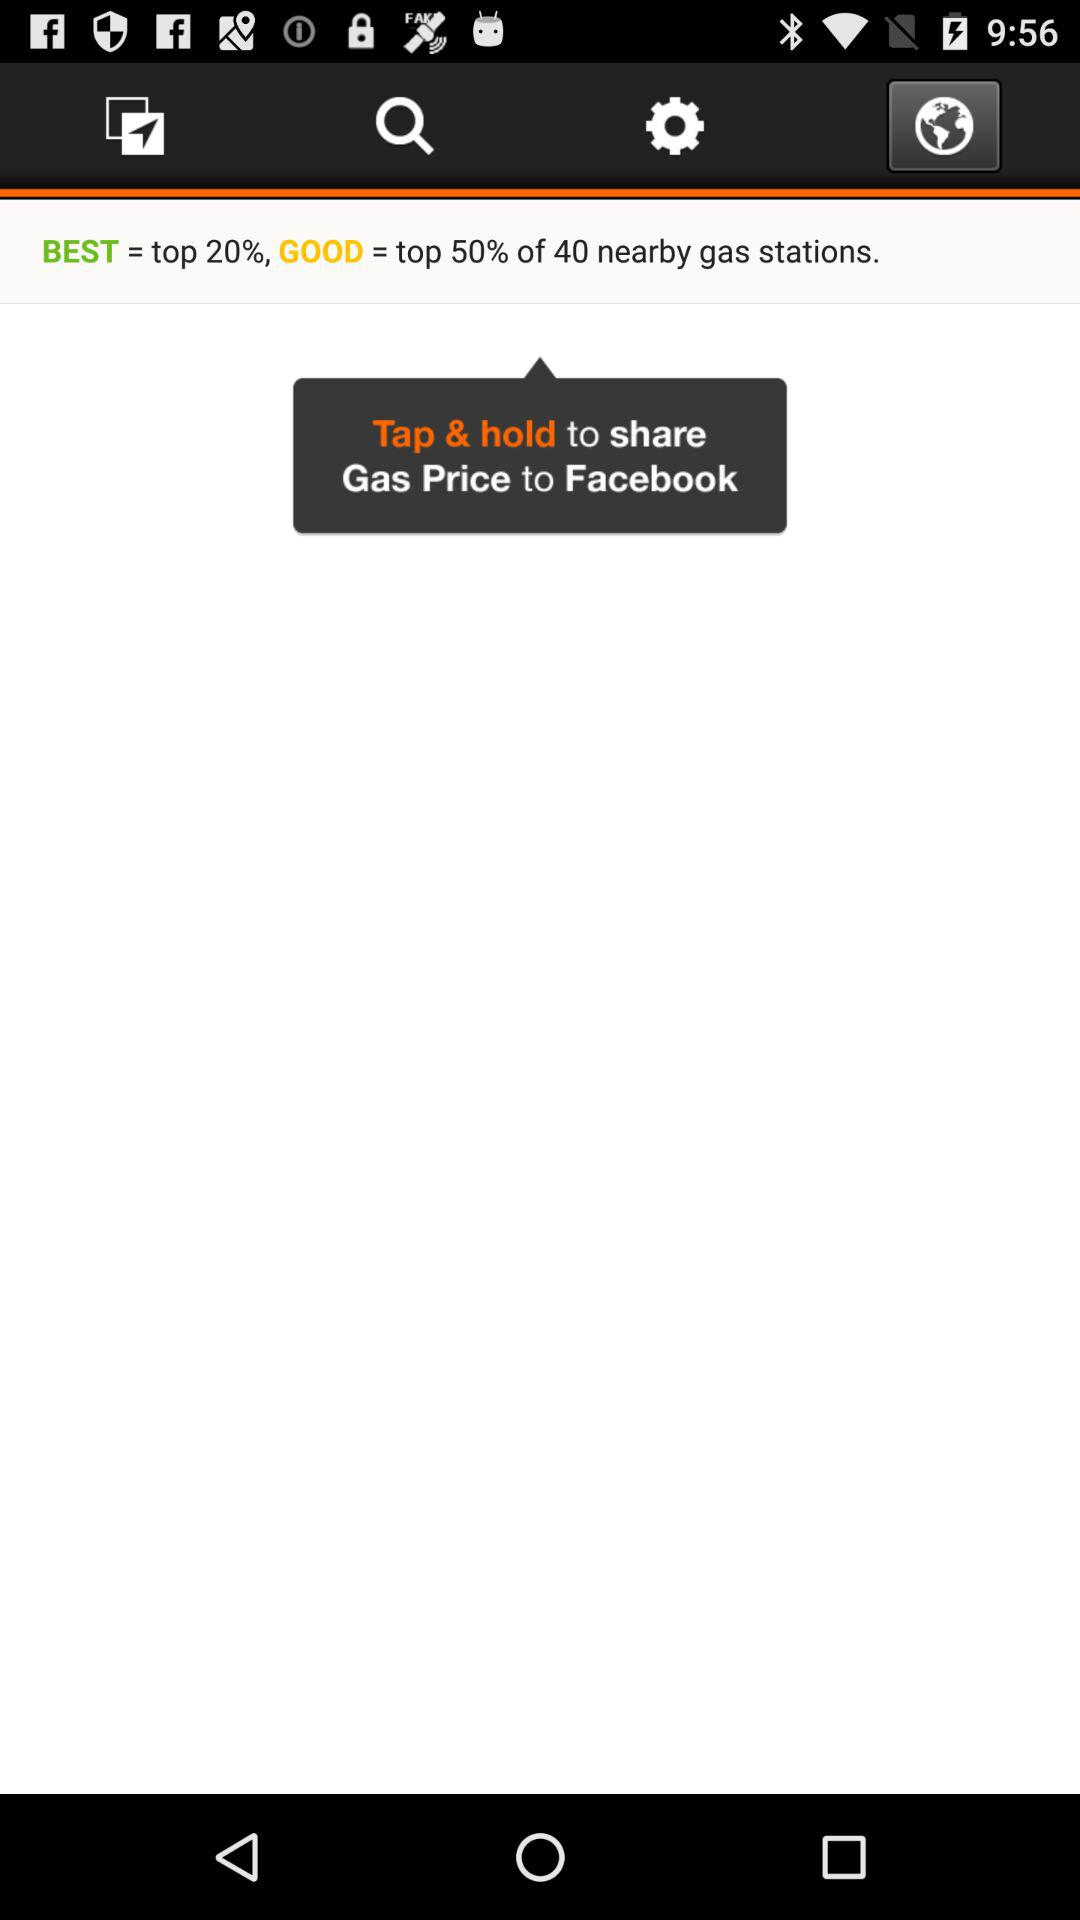Where can the gas prices be shared? The gas prices can be shared on "Facebook". 